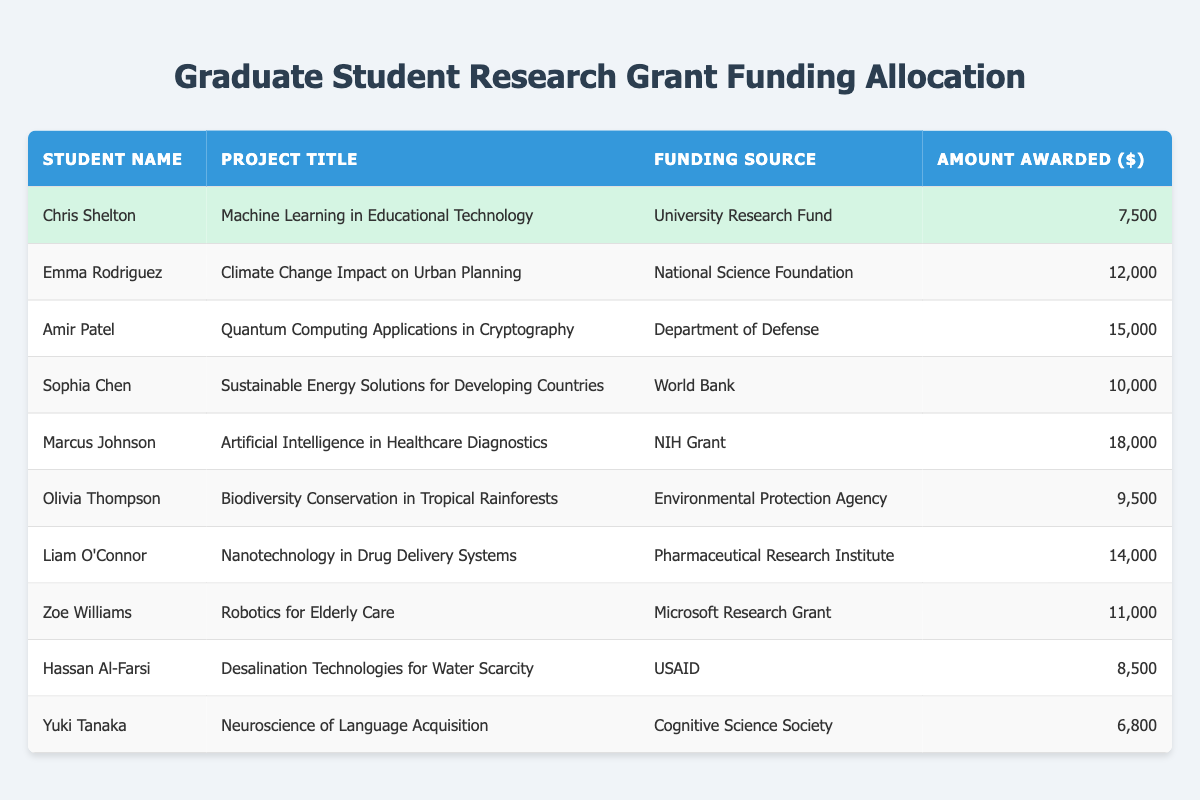What is the highest amount awarded among the students? By examining the "Amount Awarded ($)" column, we can see that the highest value is 18,000, which corresponds to Marcus Johnson’s project.
Answer: 18000 Which student received funding from the National Science Foundation? Looking at the "Funding Source" column, Emma Rodriguez received funding from the National Science Foundation for her project.
Answer: Emma Rodriguez What is the total amount awarded to Chris Shelton and Yuki Tanaka? To find the total, we add Chris Shelton's amount (7,500) and Yuki Tanaka's amount (6,800), which equals 14,300.
Answer: 14300 Did Olivia Thompson receive more funding than Zoe Williams? By comparing the amounts in the "Amount Awarded ($)" column, Olivia received 9,500 and Zoe received 11,000. Since 9,500 is less than 11,000, the statement is false.
Answer: No What is the average amount awarded to students funded by the World Bank and the Environmental Protection Agency? The two students, Sophia Chen (10,000) and Olivia Thompson (9,500), received funding from these sources, respectively. Adding their amounts gives us 19,500. There are 2 students, so the average is 19,500 divided by 2, resulting in 9,750.
Answer: 9750 Which project received the least amount of funding? Reviewing the "Amount Awarded ($)" column reveals that Yuki Tanaka’s project received the least amount with 6,800.
Answer: 6800 How many students received funding from the USAID? The table shows that only one student, Hassan Al-Farsi, received funding from USAID, as indicated in the "Funding Source" column.
Answer: 1 What is the funding source for the project titled "Robotics for Elderly Care"? In the "Project Title" column, we find that Zoe Williams's project, "Robotics for Elderly Care," is funded by the Microsoft Research Grant.
Answer: Microsoft Research Grant 